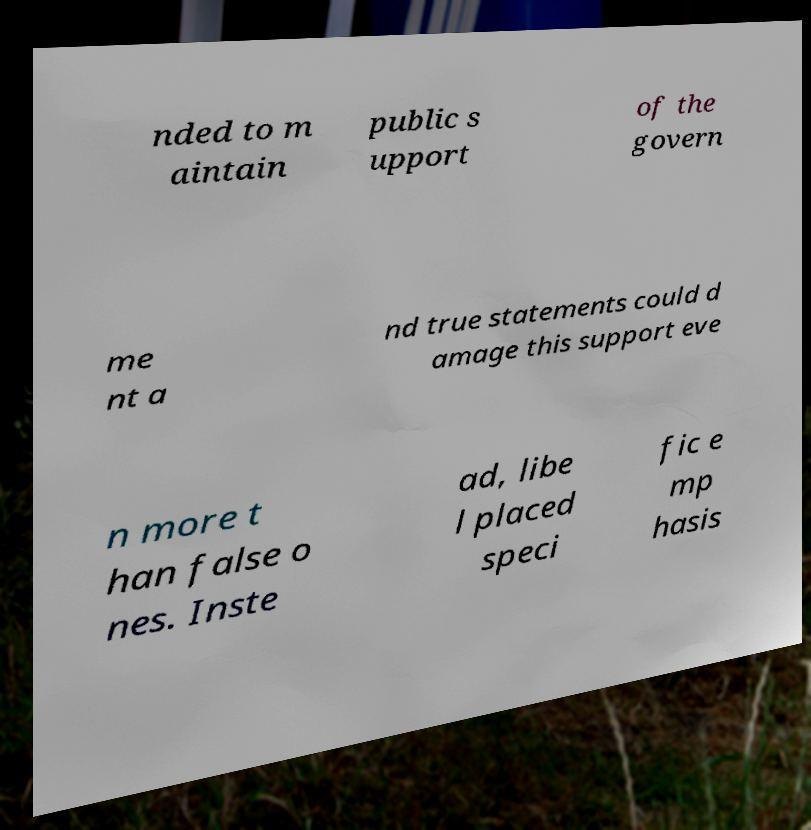There's text embedded in this image that I need extracted. Can you transcribe it verbatim? nded to m aintain public s upport of the govern me nt a nd true statements could d amage this support eve n more t han false o nes. Inste ad, libe l placed speci fic e mp hasis 